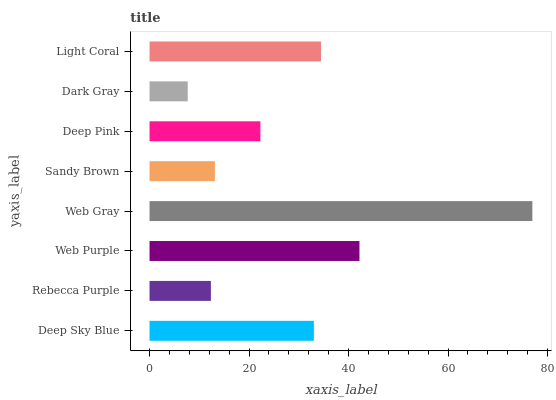Is Dark Gray the minimum?
Answer yes or no. Yes. Is Web Gray the maximum?
Answer yes or no. Yes. Is Rebecca Purple the minimum?
Answer yes or no. No. Is Rebecca Purple the maximum?
Answer yes or no. No. Is Deep Sky Blue greater than Rebecca Purple?
Answer yes or no. Yes. Is Rebecca Purple less than Deep Sky Blue?
Answer yes or no. Yes. Is Rebecca Purple greater than Deep Sky Blue?
Answer yes or no. No. Is Deep Sky Blue less than Rebecca Purple?
Answer yes or no. No. Is Deep Sky Blue the high median?
Answer yes or no. Yes. Is Deep Pink the low median?
Answer yes or no. Yes. Is Deep Pink the high median?
Answer yes or no. No. Is Web Gray the low median?
Answer yes or no. No. 